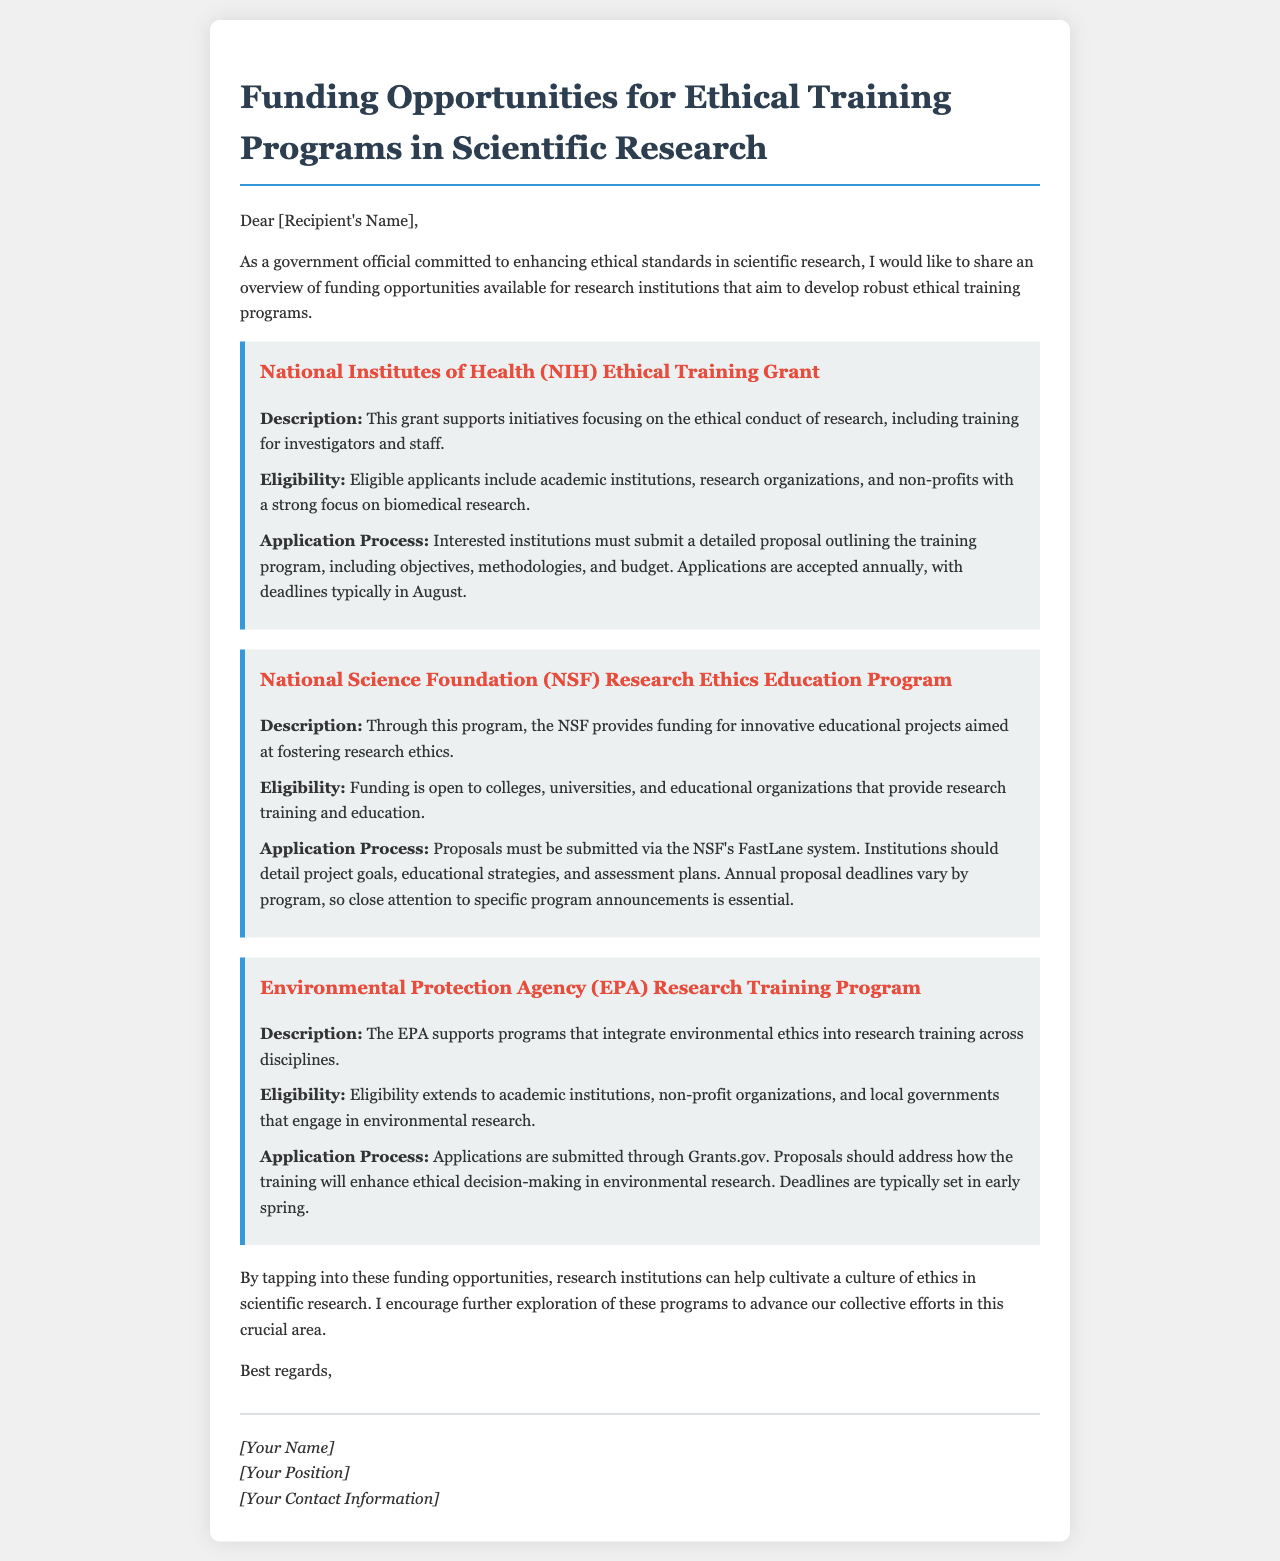What is the title of the document? The title is found at the beginning of the document, summarizing its content.
Answer: Funding Opportunities for Ethical Training Programs in Scientific Research How many funding opportunities are mentioned? The document lists three distinct funding opportunities.
Answer: Three What is the application deadline for the NIH Ethical Training Grant? The application deadline is specified as typically occurring in August each year.
Answer: August Who is eligible for the NSF Research Ethics Education Program? The document details that colleges, universities, and educational organizations can apply.
Answer: Colleges, universities, and educational organizations What system do institutions use to submit proposals to the NSF? The submission process for the NSF is through the specified platform in the document.
Answer: NSF's FastLane system Which agency supports programs integrating environmental ethics? The document explicitly mentions the agency responsible for such support.
Answer: Environmental Protection Agency (EPA) What type of organizations can apply for the EPA Research Training Program? Eligibility criteria are noted in the document for organizations that can apply.
Answer: Academic institutions, non-profit organizations, and local governments What is a common requirement for proposals in all the funding opportunities? The document states that proposals must outline certain key aspects, applicable across the opportunities.
Answer: Detailed proposal outlining the training program 